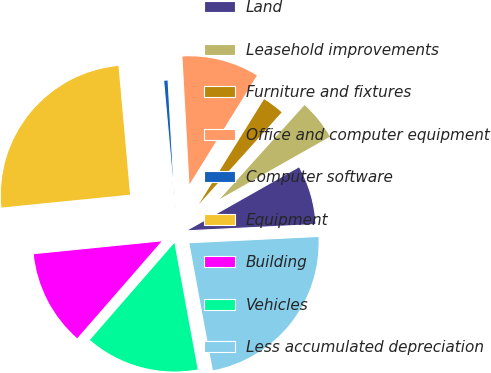<chart> <loc_0><loc_0><loc_500><loc_500><pie_chart><fcel>Land<fcel>Leasehold improvements<fcel>Furniture and fixtures<fcel>Office and computer equipment<fcel>Computer software<fcel>Equipment<fcel>Building<fcel>Vehicles<fcel>Less accumulated depreciation<nl><fcel>7.42%<fcel>5.13%<fcel>2.84%<fcel>9.71%<fcel>0.55%<fcel>25.16%<fcel>12.01%<fcel>14.3%<fcel>22.87%<nl></chart> 